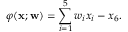Convert formula to latex. <formula><loc_0><loc_0><loc_500><loc_500>\varphi ( x ; w ) = \sum _ { i = 1 } ^ { 5 } w _ { i } x _ { i } - x _ { 6 } .</formula> 